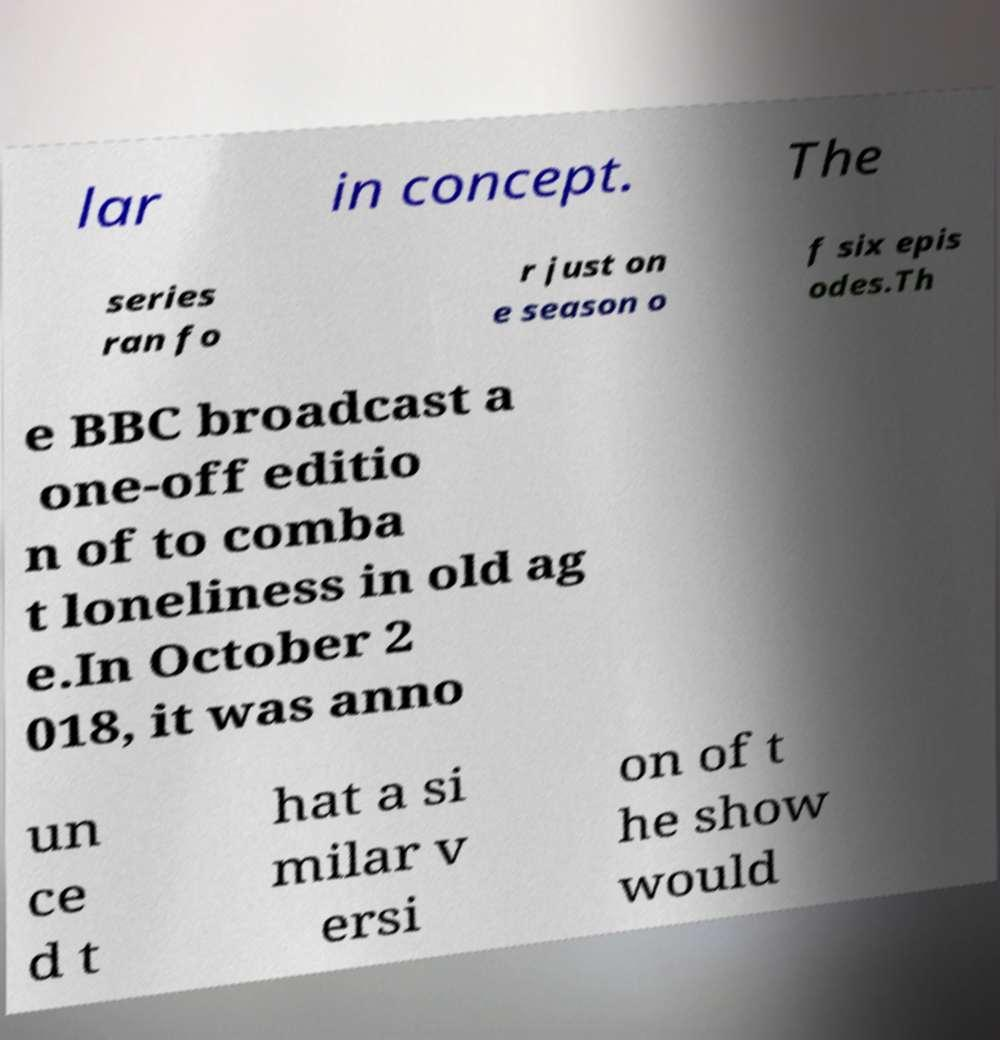There's text embedded in this image that I need extracted. Can you transcribe it verbatim? lar in concept. The series ran fo r just on e season o f six epis odes.Th e BBC broadcast a one-off editio n of to comba t loneliness in old ag e.In October 2 018, it was anno un ce d t hat a si milar v ersi on of t he show would 